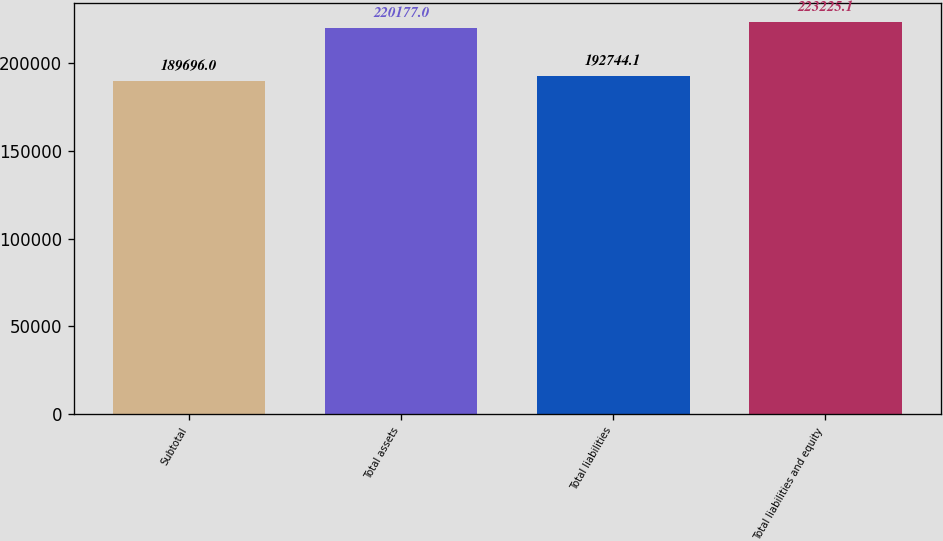Convert chart to OTSL. <chart><loc_0><loc_0><loc_500><loc_500><bar_chart><fcel>Subtotal<fcel>Total assets<fcel>Total liabilities<fcel>Total liabilities and equity<nl><fcel>189696<fcel>220177<fcel>192744<fcel>223225<nl></chart> 